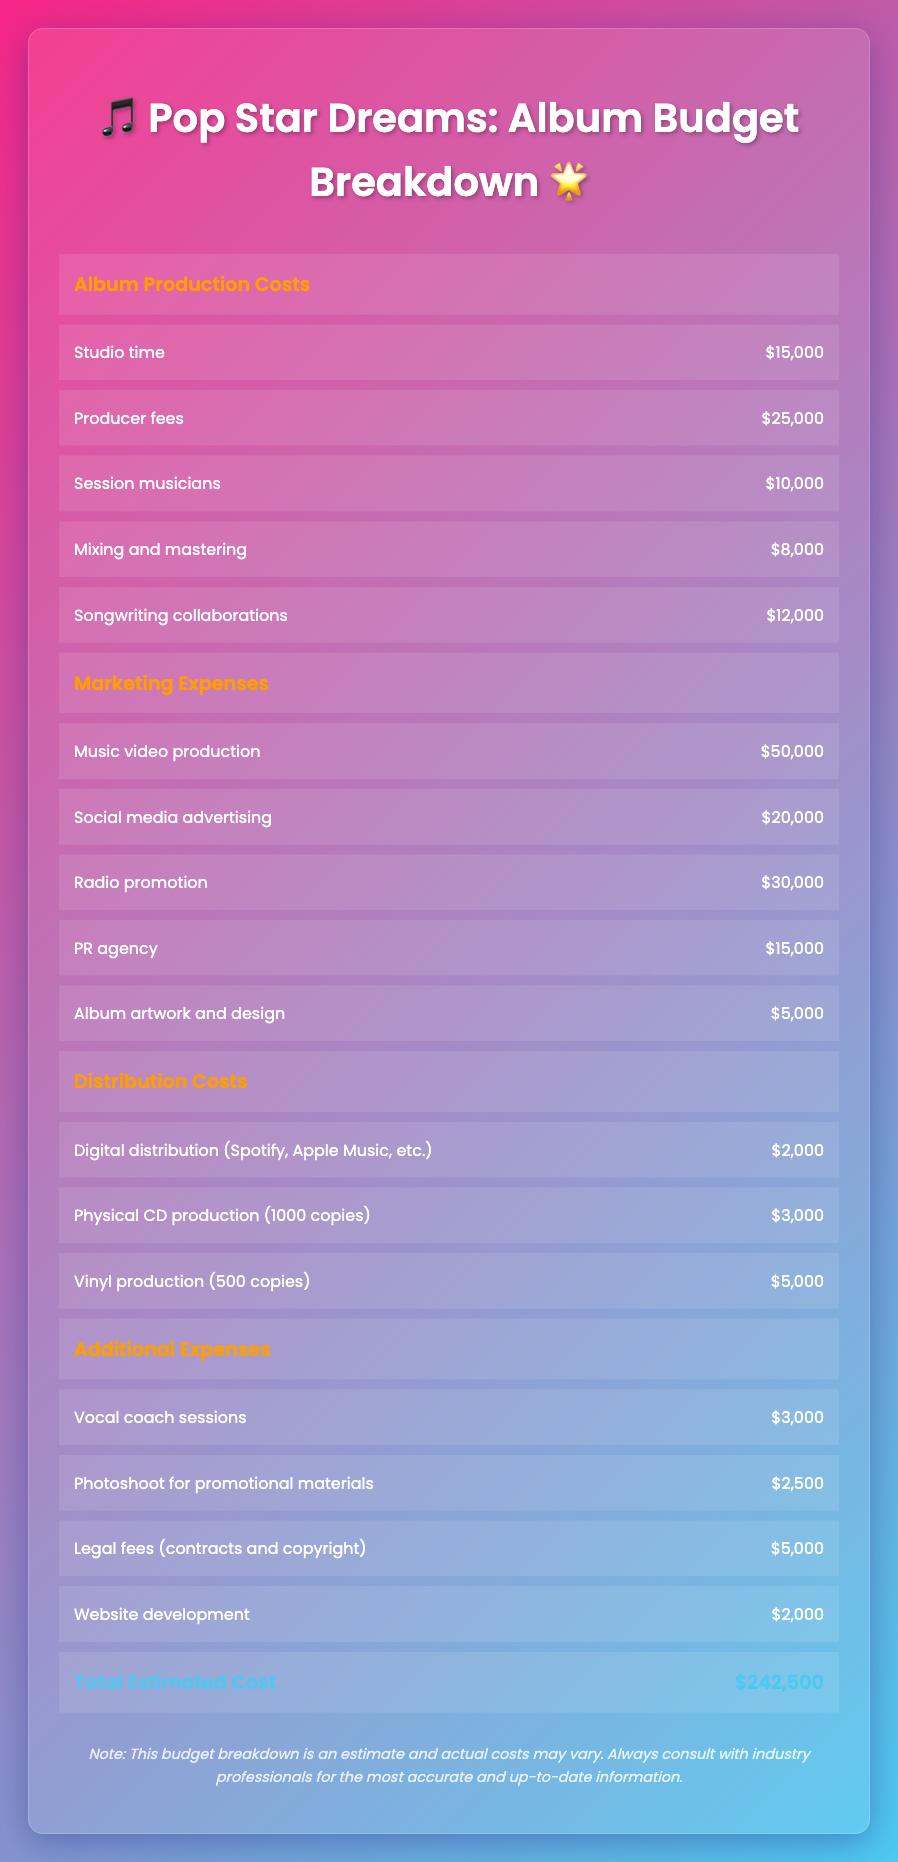What is the total cost for album production? To find the total cost for album production, we sum the costs of all individual items listed under album production costs: $15,000 (Studio time) + $25,000 (Producer fees) + $10,000 (Session musicians) + $8,000 (Mixing and mastering) + $12,000 (Songwriting collaborations) = $70,000.
Answer: $70,000 How much is allocated for marketing expenses? We add the costs of all marketing expenses: $50,000 (Music video production) + $20,000 (Social media advertising) + $30,000 (Radio promotion) + $15,000 (PR agency) + $5,000 (Album artwork and design) = $120,000.
Answer: $120,000 Is the cost for physical CD production greater than the cost for digital distribution? Comparing the two costs, physical CD production is $3,000 while digital distribution is $2,000. As $3,000 is greater than $2,000, the statement is true.
Answer: Yes What is the average cost of the additional expenses? To calculate the average, first, we sum the costs under additional expenses: $3,000 (Vocal coach sessions) + $2,500 (Photoshoot) + $5,000 (Legal fees) + $2,000 (Website development) = $12,500. There are 4 items, so we divide $12,500 by 4 to get $3,125 as the average cost.
Answer: $3,125 Which single expense has the highest cost in the marketing expenses section? By reviewing the marketing expenses, we see that Music video production at $50,000 is the highest among the items listed: $50,000, $20,000, $30,000, $15,000, and $5,000.
Answer: Music video production What is the combined cost of vinyl and digital production? Adding these two costs gives us: $5,000 (Vinyl production) + $2,000 (Digital distribution) = $7,000 total.
Answer: $7,000 How much less is the total estimated cost compared to the combined cost of album production and marketing expenses? First, the total estimated cost is $242,500. Then, we add album production costs ($70,000) and marketing expenses ($120,000), which total $190,000. Now subtract: $242,500 - $190,000 = $52,500 indicates the difference.
Answer: $52,500 Are the costs for session musicians and vocal coach sessions both under $5,000? The costs are: $10,000 (Session musicians) and $3,000 (Vocal coach sessions). Since $10,000 is not under $5,000, the statement is false.
Answer: No 